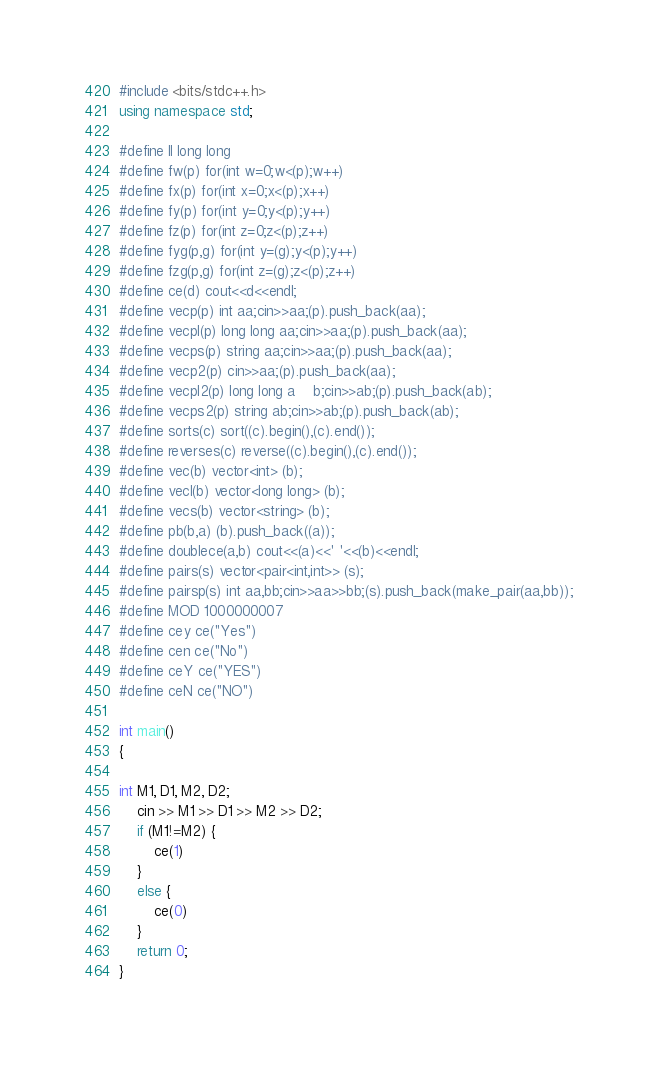<code> <loc_0><loc_0><loc_500><loc_500><_C++_>#include <bits/stdc++.h>
using namespace std;

#define ll long long
#define fw(p) for(int w=0;w<(p);w++)
#define fx(p) for(int x=0;x<(p);x++)
#define fy(p) for(int y=0;y<(p);y++)
#define fz(p) for(int z=0;z<(p);z++)
#define fyg(p,g) for(int y=(g);y<(p);y++)
#define fzg(p,g) for(int z=(g);z<(p);z++)
#define ce(d) cout<<d<<endl;
#define vecp(p) int aa;cin>>aa;(p).push_back(aa);
#define vecpl(p) long long aa;cin>>aa;(p).push_back(aa);
#define vecps(p) string aa;cin>>aa;(p).push_back(aa);
#define vecp2(p) cin>>aa;(p).push_back(aa);
#define vecpl2(p) long long a	b;cin>>ab;(p).push_back(ab);
#define vecps2(p) string ab;cin>>ab;(p).push_back(ab);
#define sorts(c) sort((c).begin(),(c).end());
#define reverses(c) reverse((c).begin(),(c).end());
#define vec(b) vector<int> (b);
#define vecl(b) vector<long long> (b);
#define vecs(b) vector<string> (b);
#define pb(b,a) (b).push_back((a));
#define doublece(a,b) cout<<(a)<<' '<<(b)<<endl;
#define pairs(s) vector<pair<int,int>> (s);
#define pairsp(s) int aa,bb;cin>>aa>>bb;(s).push_back(make_pair(aa,bb));
#define MOD 1000000007
#define cey ce("Yes")
#define cen ce("No")
#define ceY ce("YES")
#define ceN ce("NO")

int main()
{

int M1, D1, M2, D2;
	cin >> M1 >> D1 >> M2 >> D2;
	if (M1!=M2) {
		ce(1)
	}
	else {
		ce(0)
	}
    return 0;
}

</code> 